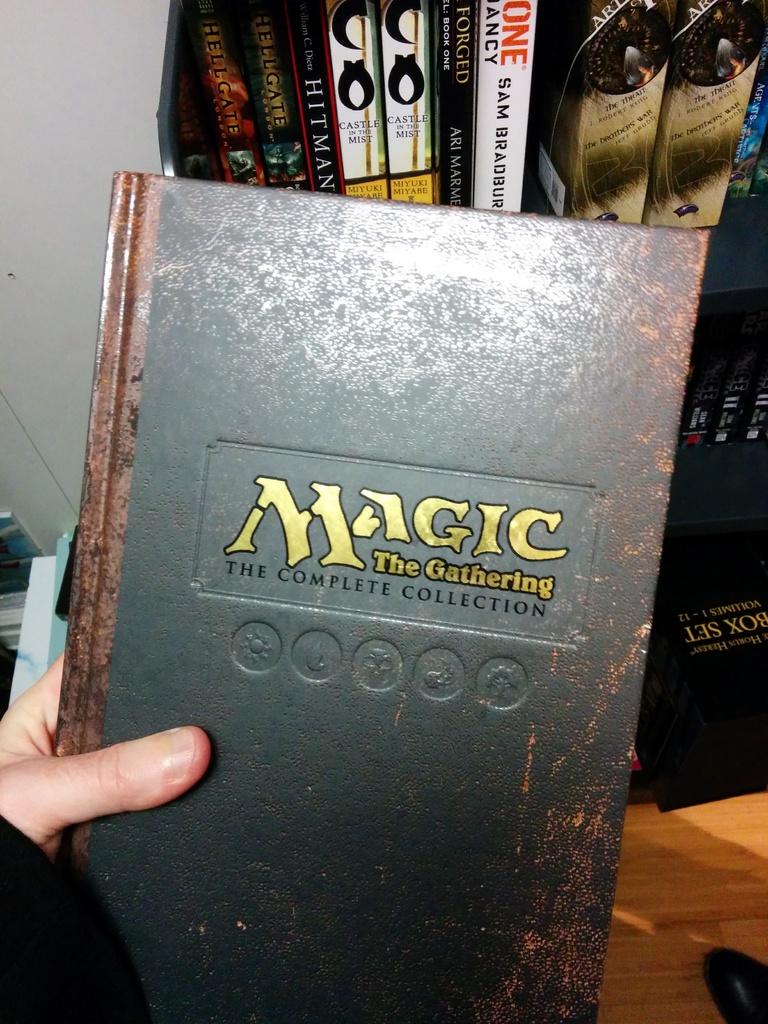What sort of collection is it?
Offer a very short reply. Magic the gathering. 